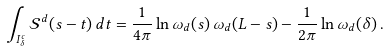<formula> <loc_0><loc_0><loc_500><loc_500>\int _ { I ^ { c } _ { \delta } } \mathcal { S } ^ { d } ( s - t ) \, d t = \frac { 1 } { 4 \pi } \ln \omega _ { d } ( s ) \, \omega _ { d } ( L - s ) - \frac { 1 } { 2 \pi } \ln \omega _ { d } ( \delta ) \, .</formula> 